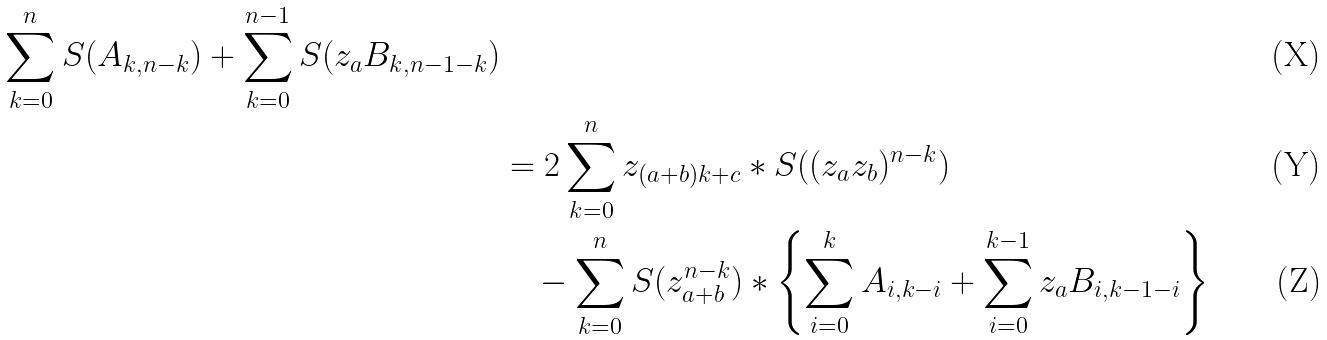Convert formula to latex. <formula><loc_0><loc_0><loc_500><loc_500>{ \sum _ { k = 0 } ^ { n } S ( A _ { k , n - k } ) + \sum _ { k = 0 } ^ { n - 1 } S ( z _ { a } B _ { k , n - 1 - k } ) } \\ & = 2 \sum _ { k = 0 } ^ { n } z _ { ( a + b ) k + c } * S ( ( z _ { a } z _ { b } ) ^ { n - k } ) \\ & \quad - \sum _ { k = 0 } ^ { n } S ( z _ { a + b } ^ { n - k } ) * \left \{ \sum _ { i = 0 } ^ { k } A _ { i , k - i } + \sum _ { i = 0 } ^ { k - 1 } z _ { a } B _ { i , k - 1 - i } \right \}</formula> 